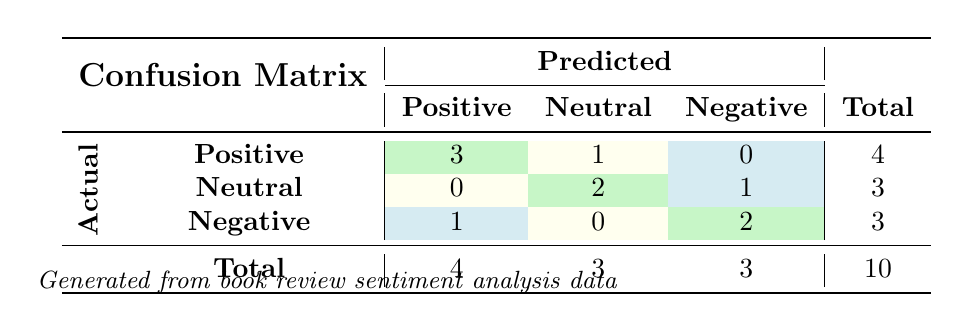What is the total number of actual positive reviews? To find the total number of actual positive reviews, we look at the row labeled "Positive" in the "Actual" column. The total in that row is 4, which represents the total number of instances that were actually positive.
Answer: 4 How many reviews were incorrectly classified as Negative? To determine the number of reviews incorrectly classified as Negative, we look at the predictions made for "Actual Positive" and "Actual Neutral". In the "Actual Positive" row, 0 reviews were predicted as Negative, and in the "Actual Neutral" row, 1 review was predicted as Negative. So, the total is 0 + 1 = 1.
Answer: 1 What is the precision for positive sentiment? Precision for positive sentiment is calculated as the number of true positives divided by the total predicted positives. There are 3 true positives (predicted as Positive when they are Positive) and 4 total predicted as Positive. The precision is 3/4 = 0.75 or 75%.
Answer: 75% How many total reviews were classified as Neutral? To find out how many reviews were classified as Neutral, we look at the "Total" column in the "Predicted" row under Neutral. The total value there is 3, indicating that 3 reviews were predicted as Neutral.
Answer: 3 Was there any review that was predicted as Positive but was actually Neutral? We need to examine the "Actual Neutral" row to see the predictions made for that category. The "Actual Neutral" row indicates that 2 reviews were predicted as Neutral and 0 reviews as Positive. Thus, no review was predicted as Positive that was actually Neutral.
Answer: No Which sentiment had the highest misclassification? To find the sentiment with the highest misclassification, we compare the off-diagonal values in each row. The misclassifications for Positive and Neutral are 1 (Positive predicted as Negative) and 1 (Neutral predicted as Negative, and 1 Neutral predicted as Positive) respectively. The Negative sentiment row shows 1 (Negative predicted as Positive) but no predictions for Negative to Neutral. Counting misclassifications, 1 for Positive and Neutral each, so they tie with Negative.
Answer: Positive and Neutral What is the most common predicted sentiment? To find the most common predicted sentiment, we sum the values in the "Total" row for each predicted sentiment. For Positive: 4, Neutral: 3, and Negative: 3. The highest value is 4 for Positive sentiment.
Answer: Positive How many actual reviews were classified as Neutral? The number of actual reviews classified as Neutral can be found in the "Neutral" row under the "Total" column. There are 3 actual reviews labeled as Neutral total.
Answer: 3 